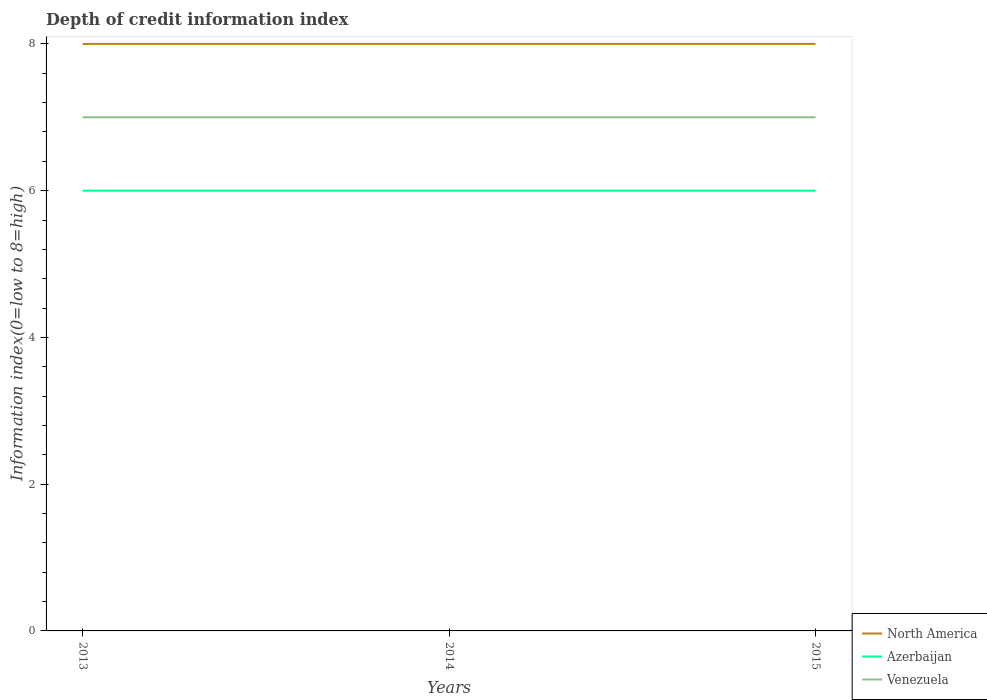How many different coloured lines are there?
Your answer should be compact. 3. Does the line corresponding to Azerbaijan intersect with the line corresponding to Venezuela?
Make the answer very short. No. Is the number of lines equal to the number of legend labels?
Provide a succinct answer. Yes. Across all years, what is the maximum information index in Venezuela?
Give a very brief answer. 7. In which year was the information index in North America maximum?
Your answer should be compact. 2013. What is the difference between the highest and the second highest information index in North America?
Provide a succinct answer. 0. How many lines are there?
Make the answer very short. 3. How many years are there in the graph?
Provide a short and direct response. 3. What is the difference between two consecutive major ticks on the Y-axis?
Ensure brevity in your answer.  2. Does the graph contain any zero values?
Keep it short and to the point. No. Where does the legend appear in the graph?
Offer a terse response. Bottom right. How many legend labels are there?
Your answer should be very brief. 3. How are the legend labels stacked?
Provide a short and direct response. Vertical. What is the title of the graph?
Offer a terse response. Depth of credit information index. Does "Tanzania" appear as one of the legend labels in the graph?
Your response must be concise. No. What is the label or title of the Y-axis?
Your answer should be compact. Information index(0=low to 8=high). What is the Information index(0=low to 8=high) of North America in 2013?
Provide a succinct answer. 8. What is the Information index(0=low to 8=high) of Azerbaijan in 2014?
Give a very brief answer. 6. What is the Information index(0=low to 8=high) in Venezuela in 2014?
Give a very brief answer. 7. What is the Information index(0=low to 8=high) of North America in 2015?
Offer a very short reply. 8. Across all years, what is the maximum Information index(0=low to 8=high) of Azerbaijan?
Offer a very short reply. 6. Across all years, what is the maximum Information index(0=low to 8=high) in Venezuela?
Ensure brevity in your answer.  7. Across all years, what is the minimum Information index(0=low to 8=high) in North America?
Give a very brief answer. 8. What is the total Information index(0=low to 8=high) in North America in the graph?
Provide a succinct answer. 24. What is the total Information index(0=low to 8=high) in Azerbaijan in the graph?
Your response must be concise. 18. What is the difference between the Information index(0=low to 8=high) of Venezuela in 2013 and that in 2014?
Your answer should be compact. 0. What is the difference between the Information index(0=low to 8=high) of Azerbaijan in 2013 and that in 2015?
Keep it short and to the point. 0. What is the difference between the Information index(0=low to 8=high) of North America in 2014 and that in 2015?
Your response must be concise. 0. What is the difference between the Information index(0=low to 8=high) of Azerbaijan in 2014 and that in 2015?
Your answer should be compact. 0. What is the difference between the Information index(0=low to 8=high) of Venezuela in 2014 and that in 2015?
Give a very brief answer. 0. What is the difference between the Information index(0=low to 8=high) in North America in 2013 and the Information index(0=low to 8=high) in Azerbaijan in 2014?
Provide a succinct answer. 2. What is the difference between the Information index(0=low to 8=high) in Azerbaijan in 2013 and the Information index(0=low to 8=high) in Venezuela in 2015?
Offer a very short reply. -1. What is the difference between the Information index(0=low to 8=high) in North America in 2014 and the Information index(0=low to 8=high) in Azerbaijan in 2015?
Ensure brevity in your answer.  2. What is the average Information index(0=low to 8=high) in North America per year?
Keep it short and to the point. 8. In the year 2013, what is the difference between the Information index(0=low to 8=high) of North America and Information index(0=low to 8=high) of Azerbaijan?
Keep it short and to the point. 2. In the year 2013, what is the difference between the Information index(0=low to 8=high) in North America and Information index(0=low to 8=high) in Venezuela?
Ensure brevity in your answer.  1. In the year 2013, what is the difference between the Information index(0=low to 8=high) of Azerbaijan and Information index(0=low to 8=high) of Venezuela?
Your response must be concise. -1. In the year 2014, what is the difference between the Information index(0=low to 8=high) in North America and Information index(0=low to 8=high) in Azerbaijan?
Your response must be concise. 2. In the year 2014, what is the difference between the Information index(0=low to 8=high) in Azerbaijan and Information index(0=low to 8=high) in Venezuela?
Provide a short and direct response. -1. In the year 2015, what is the difference between the Information index(0=low to 8=high) of North America and Information index(0=low to 8=high) of Azerbaijan?
Keep it short and to the point. 2. In the year 2015, what is the difference between the Information index(0=low to 8=high) in Azerbaijan and Information index(0=low to 8=high) in Venezuela?
Keep it short and to the point. -1. What is the ratio of the Information index(0=low to 8=high) of North America in 2013 to that in 2014?
Your response must be concise. 1. What is the ratio of the Information index(0=low to 8=high) in Azerbaijan in 2013 to that in 2014?
Your answer should be compact. 1. What is the ratio of the Information index(0=low to 8=high) of Venezuela in 2013 to that in 2014?
Your response must be concise. 1. What is the ratio of the Information index(0=low to 8=high) of North America in 2013 to that in 2015?
Ensure brevity in your answer.  1. What is the ratio of the Information index(0=low to 8=high) of Venezuela in 2013 to that in 2015?
Your answer should be very brief. 1. What is the ratio of the Information index(0=low to 8=high) of North America in 2014 to that in 2015?
Offer a terse response. 1. What is the difference between the highest and the second highest Information index(0=low to 8=high) in North America?
Ensure brevity in your answer.  0. What is the difference between the highest and the second highest Information index(0=low to 8=high) of Venezuela?
Provide a succinct answer. 0. What is the difference between the highest and the lowest Information index(0=low to 8=high) of Azerbaijan?
Give a very brief answer. 0. 